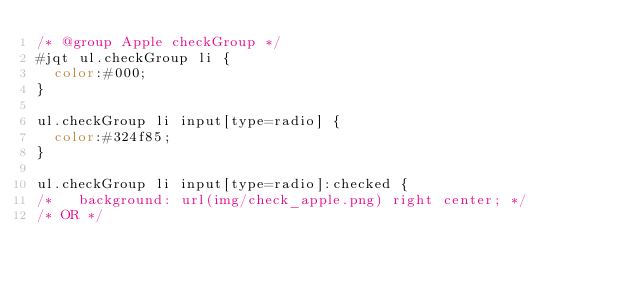Convert code to text. <code><loc_0><loc_0><loc_500><loc_500><_CSS_>/* @group Apple checkGroup */
#jqt ul.checkGroup li {
  color:#000;
}

ul.checkGroup li input[type=radio] {
  color:#324f85;
}

ul.checkGroup li input[type=radio]:checked {
/*   background: url(img/check_apple.png) right center; */
/* OR */</code> 